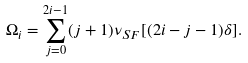Convert formula to latex. <formula><loc_0><loc_0><loc_500><loc_500>\Omega _ { i } = \sum _ { j = 0 } ^ { 2 i - 1 } ( j + 1 ) \nu _ { S F } [ ( 2 i - j - 1 ) \delta ] .</formula> 